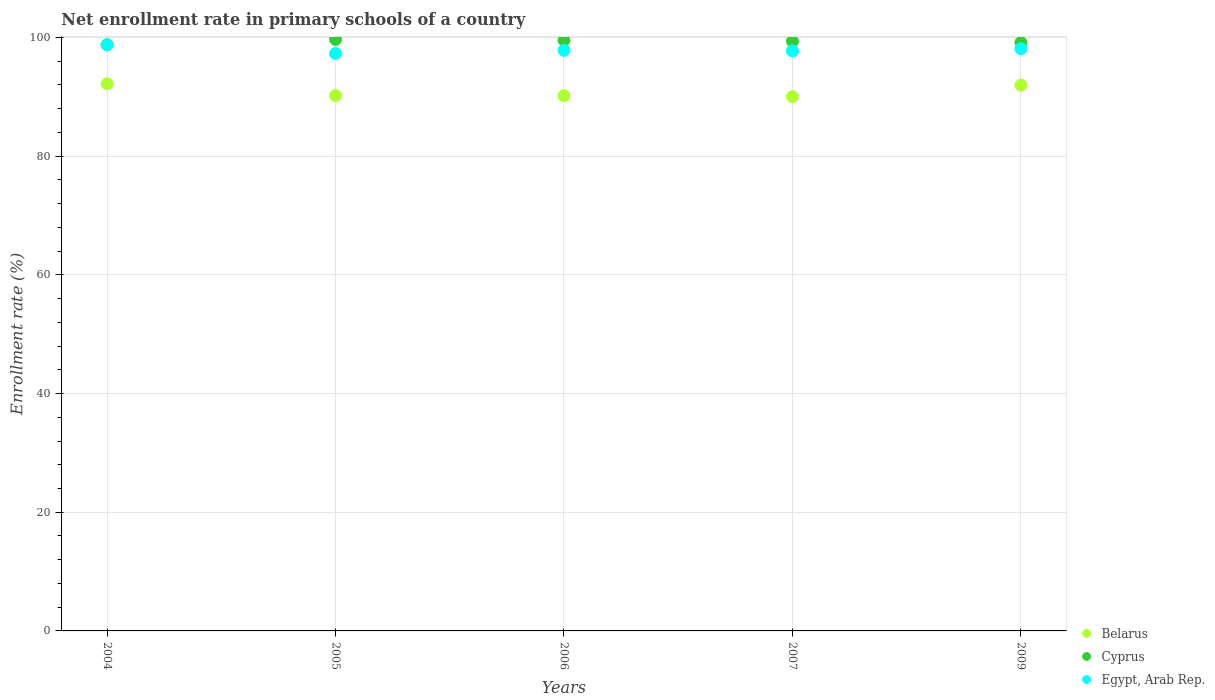How many different coloured dotlines are there?
Your answer should be very brief. 3. Is the number of dotlines equal to the number of legend labels?
Provide a short and direct response. Yes. What is the enrollment rate in primary schools in Egypt, Arab Rep. in 2004?
Give a very brief answer. 98.75. Across all years, what is the maximum enrollment rate in primary schools in Egypt, Arab Rep.?
Keep it short and to the point. 98.75. Across all years, what is the minimum enrollment rate in primary schools in Belarus?
Give a very brief answer. 90.03. In which year was the enrollment rate in primary schools in Belarus minimum?
Provide a short and direct response. 2007. What is the total enrollment rate in primary schools in Belarus in the graph?
Provide a short and direct response. 454.55. What is the difference between the enrollment rate in primary schools in Cyprus in 2004 and that in 2007?
Your response must be concise. -0.58. What is the difference between the enrollment rate in primary schools in Cyprus in 2005 and the enrollment rate in primary schools in Belarus in 2007?
Keep it short and to the point. 9.63. What is the average enrollment rate in primary schools in Egypt, Arab Rep. per year?
Keep it short and to the point. 97.93. In the year 2009, what is the difference between the enrollment rate in primary schools in Belarus and enrollment rate in primary schools in Cyprus?
Keep it short and to the point. -7.19. What is the ratio of the enrollment rate in primary schools in Belarus in 2006 to that in 2009?
Provide a succinct answer. 0.98. Is the difference between the enrollment rate in primary schools in Belarus in 2005 and 2006 greater than the difference between the enrollment rate in primary schools in Cyprus in 2005 and 2006?
Your response must be concise. No. What is the difference between the highest and the second highest enrollment rate in primary schools in Cyprus?
Offer a very short reply. 0.14. What is the difference between the highest and the lowest enrollment rate in primary schools in Belarus?
Make the answer very short. 2.16. In how many years, is the enrollment rate in primary schools in Belarus greater than the average enrollment rate in primary schools in Belarus taken over all years?
Keep it short and to the point. 2. Is the sum of the enrollment rate in primary schools in Cyprus in 2004 and 2009 greater than the maximum enrollment rate in primary schools in Belarus across all years?
Provide a short and direct response. Yes. Is it the case that in every year, the sum of the enrollment rate in primary schools in Cyprus and enrollment rate in primary schools in Belarus  is greater than the enrollment rate in primary schools in Egypt, Arab Rep.?
Provide a short and direct response. Yes. Is the enrollment rate in primary schools in Belarus strictly greater than the enrollment rate in primary schools in Egypt, Arab Rep. over the years?
Your response must be concise. No. Is the enrollment rate in primary schools in Egypt, Arab Rep. strictly less than the enrollment rate in primary schools in Cyprus over the years?
Provide a short and direct response. Yes. How many dotlines are there?
Ensure brevity in your answer.  3. Are the values on the major ticks of Y-axis written in scientific E-notation?
Your answer should be very brief. No. Does the graph contain any zero values?
Your response must be concise. No. Does the graph contain grids?
Offer a terse response. Yes. How many legend labels are there?
Provide a short and direct response. 3. What is the title of the graph?
Your response must be concise. Net enrollment rate in primary schools of a country. Does "Tajikistan" appear as one of the legend labels in the graph?
Your answer should be very brief. No. What is the label or title of the X-axis?
Your answer should be compact. Years. What is the label or title of the Y-axis?
Make the answer very short. Enrollment rate (%). What is the Enrollment rate (%) in Belarus in 2004?
Provide a succinct answer. 92.19. What is the Enrollment rate (%) in Cyprus in 2004?
Ensure brevity in your answer.  98.76. What is the Enrollment rate (%) of Egypt, Arab Rep. in 2004?
Keep it short and to the point. 98.75. What is the Enrollment rate (%) in Belarus in 2005?
Your answer should be compact. 90.19. What is the Enrollment rate (%) of Cyprus in 2005?
Your response must be concise. 99.66. What is the Enrollment rate (%) of Egypt, Arab Rep. in 2005?
Offer a very short reply. 97.29. What is the Enrollment rate (%) of Belarus in 2006?
Your response must be concise. 90.18. What is the Enrollment rate (%) in Cyprus in 2006?
Offer a very short reply. 99.52. What is the Enrollment rate (%) of Egypt, Arab Rep. in 2006?
Your answer should be compact. 97.83. What is the Enrollment rate (%) in Belarus in 2007?
Provide a succinct answer. 90.03. What is the Enrollment rate (%) of Cyprus in 2007?
Keep it short and to the point. 99.34. What is the Enrollment rate (%) in Egypt, Arab Rep. in 2007?
Ensure brevity in your answer.  97.73. What is the Enrollment rate (%) of Belarus in 2009?
Your answer should be very brief. 91.96. What is the Enrollment rate (%) of Cyprus in 2009?
Offer a terse response. 99.14. What is the Enrollment rate (%) in Egypt, Arab Rep. in 2009?
Ensure brevity in your answer.  98.09. Across all years, what is the maximum Enrollment rate (%) in Belarus?
Your answer should be compact. 92.19. Across all years, what is the maximum Enrollment rate (%) of Cyprus?
Make the answer very short. 99.66. Across all years, what is the maximum Enrollment rate (%) of Egypt, Arab Rep.?
Your response must be concise. 98.75. Across all years, what is the minimum Enrollment rate (%) of Belarus?
Offer a terse response. 90.03. Across all years, what is the minimum Enrollment rate (%) of Cyprus?
Offer a very short reply. 98.76. Across all years, what is the minimum Enrollment rate (%) in Egypt, Arab Rep.?
Ensure brevity in your answer.  97.29. What is the total Enrollment rate (%) in Belarus in the graph?
Your answer should be very brief. 454.55. What is the total Enrollment rate (%) in Cyprus in the graph?
Your response must be concise. 496.43. What is the total Enrollment rate (%) in Egypt, Arab Rep. in the graph?
Offer a very short reply. 489.67. What is the difference between the Enrollment rate (%) in Belarus in 2004 and that in 2005?
Your response must be concise. 2. What is the difference between the Enrollment rate (%) in Cyprus in 2004 and that in 2005?
Your response must be concise. -0.9. What is the difference between the Enrollment rate (%) in Egypt, Arab Rep. in 2004 and that in 2005?
Ensure brevity in your answer.  1.46. What is the difference between the Enrollment rate (%) in Belarus in 2004 and that in 2006?
Ensure brevity in your answer.  2.01. What is the difference between the Enrollment rate (%) of Cyprus in 2004 and that in 2006?
Keep it short and to the point. -0.76. What is the difference between the Enrollment rate (%) in Egypt, Arab Rep. in 2004 and that in 2006?
Offer a very short reply. 0.92. What is the difference between the Enrollment rate (%) in Belarus in 2004 and that in 2007?
Keep it short and to the point. 2.16. What is the difference between the Enrollment rate (%) in Cyprus in 2004 and that in 2007?
Your answer should be very brief. -0.58. What is the difference between the Enrollment rate (%) of Egypt, Arab Rep. in 2004 and that in 2007?
Your response must be concise. 1.02. What is the difference between the Enrollment rate (%) of Belarus in 2004 and that in 2009?
Your answer should be very brief. 0.23. What is the difference between the Enrollment rate (%) of Cyprus in 2004 and that in 2009?
Make the answer very short. -0.38. What is the difference between the Enrollment rate (%) of Egypt, Arab Rep. in 2004 and that in 2009?
Give a very brief answer. 0.66. What is the difference between the Enrollment rate (%) in Belarus in 2005 and that in 2006?
Provide a short and direct response. 0.01. What is the difference between the Enrollment rate (%) in Cyprus in 2005 and that in 2006?
Your answer should be compact. 0.14. What is the difference between the Enrollment rate (%) in Egypt, Arab Rep. in 2005 and that in 2006?
Your answer should be compact. -0.54. What is the difference between the Enrollment rate (%) of Belarus in 2005 and that in 2007?
Your answer should be compact. 0.16. What is the difference between the Enrollment rate (%) in Cyprus in 2005 and that in 2007?
Ensure brevity in your answer.  0.32. What is the difference between the Enrollment rate (%) of Egypt, Arab Rep. in 2005 and that in 2007?
Make the answer very short. -0.44. What is the difference between the Enrollment rate (%) in Belarus in 2005 and that in 2009?
Offer a very short reply. -1.77. What is the difference between the Enrollment rate (%) of Cyprus in 2005 and that in 2009?
Offer a very short reply. 0.52. What is the difference between the Enrollment rate (%) in Egypt, Arab Rep. in 2005 and that in 2009?
Offer a terse response. -0.8. What is the difference between the Enrollment rate (%) in Belarus in 2006 and that in 2007?
Provide a succinct answer. 0.15. What is the difference between the Enrollment rate (%) in Cyprus in 2006 and that in 2007?
Give a very brief answer. 0.18. What is the difference between the Enrollment rate (%) of Egypt, Arab Rep. in 2006 and that in 2007?
Ensure brevity in your answer.  0.1. What is the difference between the Enrollment rate (%) in Belarus in 2006 and that in 2009?
Your answer should be very brief. -1.78. What is the difference between the Enrollment rate (%) in Cyprus in 2006 and that in 2009?
Ensure brevity in your answer.  0.38. What is the difference between the Enrollment rate (%) of Egypt, Arab Rep. in 2006 and that in 2009?
Give a very brief answer. -0.26. What is the difference between the Enrollment rate (%) in Belarus in 2007 and that in 2009?
Keep it short and to the point. -1.93. What is the difference between the Enrollment rate (%) in Cyprus in 2007 and that in 2009?
Ensure brevity in your answer.  0.2. What is the difference between the Enrollment rate (%) of Egypt, Arab Rep. in 2007 and that in 2009?
Your response must be concise. -0.36. What is the difference between the Enrollment rate (%) of Belarus in 2004 and the Enrollment rate (%) of Cyprus in 2005?
Give a very brief answer. -7.47. What is the difference between the Enrollment rate (%) in Belarus in 2004 and the Enrollment rate (%) in Egypt, Arab Rep. in 2005?
Keep it short and to the point. -5.1. What is the difference between the Enrollment rate (%) of Cyprus in 2004 and the Enrollment rate (%) of Egypt, Arab Rep. in 2005?
Offer a very short reply. 1.47. What is the difference between the Enrollment rate (%) in Belarus in 2004 and the Enrollment rate (%) in Cyprus in 2006?
Ensure brevity in your answer.  -7.33. What is the difference between the Enrollment rate (%) in Belarus in 2004 and the Enrollment rate (%) in Egypt, Arab Rep. in 2006?
Provide a succinct answer. -5.64. What is the difference between the Enrollment rate (%) of Cyprus in 2004 and the Enrollment rate (%) of Egypt, Arab Rep. in 2006?
Offer a very short reply. 0.93. What is the difference between the Enrollment rate (%) in Belarus in 2004 and the Enrollment rate (%) in Cyprus in 2007?
Make the answer very short. -7.15. What is the difference between the Enrollment rate (%) in Belarus in 2004 and the Enrollment rate (%) in Egypt, Arab Rep. in 2007?
Provide a succinct answer. -5.54. What is the difference between the Enrollment rate (%) in Cyprus in 2004 and the Enrollment rate (%) in Egypt, Arab Rep. in 2007?
Your answer should be compact. 1.03. What is the difference between the Enrollment rate (%) of Belarus in 2004 and the Enrollment rate (%) of Cyprus in 2009?
Your answer should be compact. -6.95. What is the difference between the Enrollment rate (%) in Belarus in 2004 and the Enrollment rate (%) in Egypt, Arab Rep. in 2009?
Ensure brevity in your answer.  -5.9. What is the difference between the Enrollment rate (%) of Cyprus in 2004 and the Enrollment rate (%) of Egypt, Arab Rep. in 2009?
Offer a very short reply. 0.67. What is the difference between the Enrollment rate (%) in Belarus in 2005 and the Enrollment rate (%) in Cyprus in 2006?
Your response must be concise. -9.33. What is the difference between the Enrollment rate (%) in Belarus in 2005 and the Enrollment rate (%) in Egypt, Arab Rep. in 2006?
Provide a short and direct response. -7.64. What is the difference between the Enrollment rate (%) of Cyprus in 2005 and the Enrollment rate (%) of Egypt, Arab Rep. in 2006?
Your answer should be very brief. 1.84. What is the difference between the Enrollment rate (%) of Belarus in 2005 and the Enrollment rate (%) of Cyprus in 2007?
Give a very brief answer. -9.15. What is the difference between the Enrollment rate (%) in Belarus in 2005 and the Enrollment rate (%) in Egypt, Arab Rep. in 2007?
Offer a terse response. -7.54. What is the difference between the Enrollment rate (%) in Cyprus in 2005 and the Enrollment rate (%) in Egypt, Arab Rep. in 2007?
Provide a succinct answer. 1.94. What is the difference between the Enrollment rate (%) in Belarus in 2005 and the Enrollment rate (%) in Cyprus in 2009?
Your response must be concise. -8.96. What is the difference between the Enrollment rate (%) of Belarus in 2005 and the Enrollment rate (%) of Egypt, Arab Rep. in 2009?
Give a very brief answer. -7.9. What is the difference between the Enrollment rate (%) in Cyprus in 2005 and the Enrollment rate (%) in Egypt, Arab Rep. in 2009?
Your response must be concise. 1.58. What is the difference between the Enrollment rate (%) of Belarus in 2006 and the Enrollment rate (%) of Cyprus in 2007?
Offer a very short reply. -9.16. What is the difference between the Enrollment rate (%) of Belarus in 2006 and the Enrollment rate (%) of Egypt, Arab Rep. in 2007?
Offer a terse response. -7.55. What is the difference between the Enrollment rate (%) of Cyprus in 2006 and the Enrollment rate (%) of Egypt, Arab Rep. in 2007?
Offer a terse response. 1.79. What is the difference between the Enrollment rate (%) in Belarus in 2006 and the Enrollment rate (%) in Cyprus in 2009?
Ensure brevity in your answer.  -8.96. What is the difference between the Enrollment rate (%) in Belarus in 2006 and the Enrollment rate (%) in Egypt, Arab Rep. in 2009?
Your response must be concise. -7.9. What is the difference between the Enrollment rate (%) of Cyprus in 2006 and the Enrollment rate (%) of Egypt, Arab Rep. in 2009?
Your response must be concise. 1.43. What is the difference between the Enrollment rate (%) in Belarus in 2007 and the Enrollment rate (%) in Cyprus in 2009?
Offer a very short reply. -9.12. What is the difference between the Enrollment rate (%) of Belarus in 2007 and the Enrollment rate (%) of Egypt, Arab Rep. in 2009?
Offer a terse response. -8.06. What is the difference between the Enrollment rate (%) in Cyprus in 2007 and the Enrollment rate (%) in Egypt, Arab Rep. in 2009?
Make the answer very short. 1.26. What is the average Enrollment rate (%) of Belarus per year?
Your response must be concise. 90.91. What is the average Enrollment rate (%) in Cyprus per year?
Make the answer very short. 99.29. What is the average Enrollment rate (%) in Egypt, Arab Rep. per year?
Ensure brevity in your answer.  97.93. In the year 2004, what is the difference between the Enrollment rate (%) of Belarus and Enrollment rate (%) of Cyprus?
Give a very brief answer. -6.57. In the year 2004, what is the difference between the Enrollment rate (%) of Belarus and Enrollment rate (%) of Egypt, Arab Rep.?
Your response must be concise. -6.56. In the year 2004, what is the difference between the Enrollment rate (%) of Cyprus and Enrollment rate (%) of Egypt, Arab Rep.?
Offer a terse response. 0.01. In the year 2005, what is the difference between the Enrollment rate (%) in Belarus and Enrollment rate (%) in Cyprus?
Provide a short and direct response. -9.47. In the year 2005, what is the difference between the Enrollment rate (%) of Belarus and Enrollment rate (%) of Egypt, Arab Rep.?
Your answer should be very brief. -7.1. In the year 2005, what is the difference between the Enrollment rate (%) in Cyprus and Enrollment rate (%) in Egypt, Arab Rep.?
Make the answer very short. 2.37. In the year 2006, what is the difference between the Enrollment rate (%) of Belarus and Enrollment rate (%) of Cyprus?
Give a very brief answer. -9.34. In the year 2006, what is the difference between the Enrollment rate (%) in Belarus and Enrollment rate (%) in Egypt, Arab Rep.?
Your answer should be very brief. -7.64. In the year 2006, what is the difference between the Enrollment rate (%) of Cyprus and Enrollment rate (%) of Egypt, Arab Rep.?
Give a very brief answer. 1.69. In the year 2007, what is the difference between the Enrollment rate (%) in Belarus and Enrollment rate (%) in Cyprus?
Provide a succinct answer. -9.31. In the year 2007, what is the difference between the Enrollment rate (%) in Belarus and Enrollment rate (%) in Egypt, Arab Rep.?
Offer a very short reply. -7.7. In the year 2007, what is the difference between the Enrollment rate (%) of Cyprus and Enrollment rate (%) of Egypt, Arab Rep.?
Provide a short and direct response. 1.62. In the year 2009, what is the difference between the Enrollment rate (%) in Belarus and Enrollment rate (%) in Cyprus?
Make the answer very short. -7.19. In the year 2009, what is the difference between the Enrollment rate (%) in Belarus and Enrollment rate (%) in Egypt, Arab Rep.?
Make the answer very short. -6.13. In the year 2009, what is the difference between the Enrollment rate (%) in Cyprus and Enrollment rate (%) in Egypt, Arab Rep.?
Offer a terse response. 1.06. What is the ratio of the Enrollment rate (%) in Belarus in 2004 to that in 2005?
Your answer should be compact. 1.02. What is the ratio of the Enrollment rate (%) of Egypt, Arab Rep. in 2004 to that in 2005?
Provide a short and direct response. 1.01. What is the ratio of the Enrollment rate (%) in Belarus in 2004 to that in 2006?
Make the answer very short. 1.02. What is the ratio of the Enrollment rate (%) of Cyprus in 2004 to that in 2006?
Make the answer very short. 0.99. What is the ratio of the Enrollment rate (%) of Egypt, Arab Rep. in 2004 to that in 2006?
Your answer should be compact. 1.01. What is the ratio of the Enrollment rate (%) in Cyprus in 2004 to that in 2007?
Your answer should be very brief. 0.99. What is the ratio of the Enrollment rate (%) in Egypt, Arab Rep. in 2004 to that in 2007?
Your response must be concise. 1.01. What is the ratio of the Enrollment rate (%) in Egypt, Arab Rep. in 2004 to that in 2009?
Provide a succinct answer. 1.01. What is the ratio of the Enrollment rate (%) of Belarus in 2005 to that in 2006?
Offer a very short reply. 1. What is the ratio of the Enrollment rate (%) of Cyprus in 2005 to that in 2006?
Keep it short and to the point. 1. What is the ratio of the Enrollment rate (%) of Egypt, Arab Rep. in 2005 to that in 2006?
Provide a succinct answer. 0.99. What is the ratio of the Enrollment rate (%) of Belarus in 2005 to that in 2009?
Ensure brevity in your answer.  0.98. What is the ratio of the Enrollment rate (%) in Cyprus in 2005 to that in 2009?
Ensure brevity in your answer.  1.01. What is the ratio of the Enrollment rate (%) in Belarus in 2006 to that in 2007?
Offer a terse response. 1. What is the ratio of the Enrollment rate (%) in Egypt, Arab Rep. in 2006 to that in 2007?
Give a very brief answer. 1. What is the ratio of the Enrollment rate (%) of Belarus in 2006 to that in 2009?
Your answer should be very brief. 0.98. What is the ratio of the Enrollment rate (%) in Egypt, Arab Rep. in 2006 to that in 2009?
Provide a succinct answer. 1. What is the ratio of the Enrollment rate (%) of Cyprus in 2007 to that in 2009?
Provide a short and direct response. 1. What is the ratio of the Enrollment rate (%) in Egypt, Arab Rep. in 2007 to that in 2009?
Provide a short and direct response. 1. What is the difference between the highest and the second highest Enrollment rate (%) in Belarus?
Make the answer very short. 0.23. What is the difference between the highest and the second highest Enrollment rate (%) of Cyprus?
Give a very brief answer. 0.14. What is the difference between the highest and the second highest Enrollment rate (%) of Egypt, Arab Rep.?
Offer a terse response. 0.66. What is the difference between the highest and the lowest Enrollment rate (%) of Belarus?
Provide a succinct answer. 2.16. What is the difference between the highest and the lowest Enrollment rate (%) of Cyprus?
Give a very brief answer. 0.9. What is the difference between the highest and the lowest Enrollment rate (%) of Egypt, Arab Rep.?
Your answer should be very brief. 1.46. 